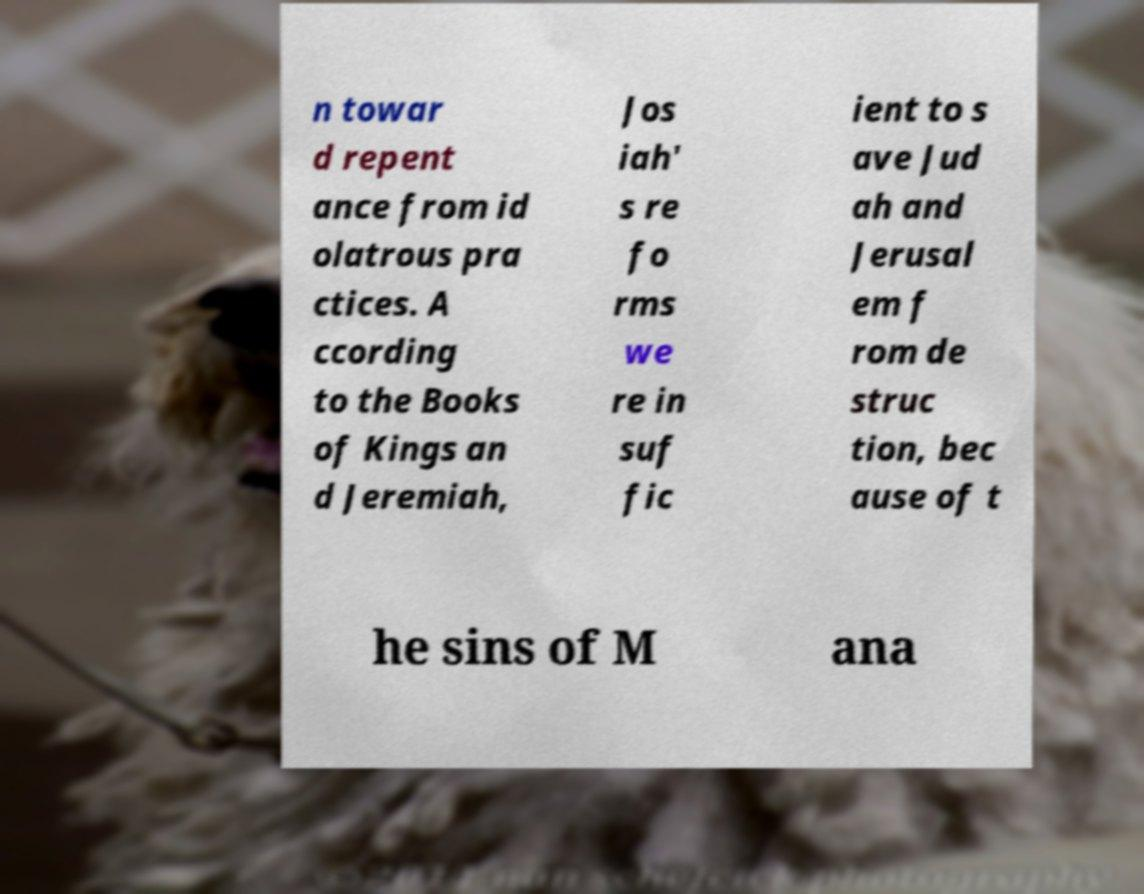Please read and relay the text visible in this image. What does it say? n towar d repent ance from id olatrous pra ctices. A ccording to the Books of Kings an d Jeremiah, Jos iah' s re fo rms we re in suf fic ient to s ave Jud ah and Jerusal em f rom de struc tion, bec ause of t he sins of M ana 